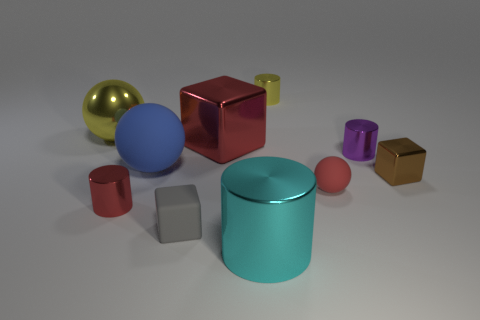There is a blue thing; is its size the same as the red cylinder on the left side of the gray object? No, the blue sphere is larger than the red cylinder located to the left of the gray cube. The blue sphere is of a considerable size which seems to dominate the collection of objects, whereas the red cylinder is smaller in both height and diameter compared to the blue sphere. 